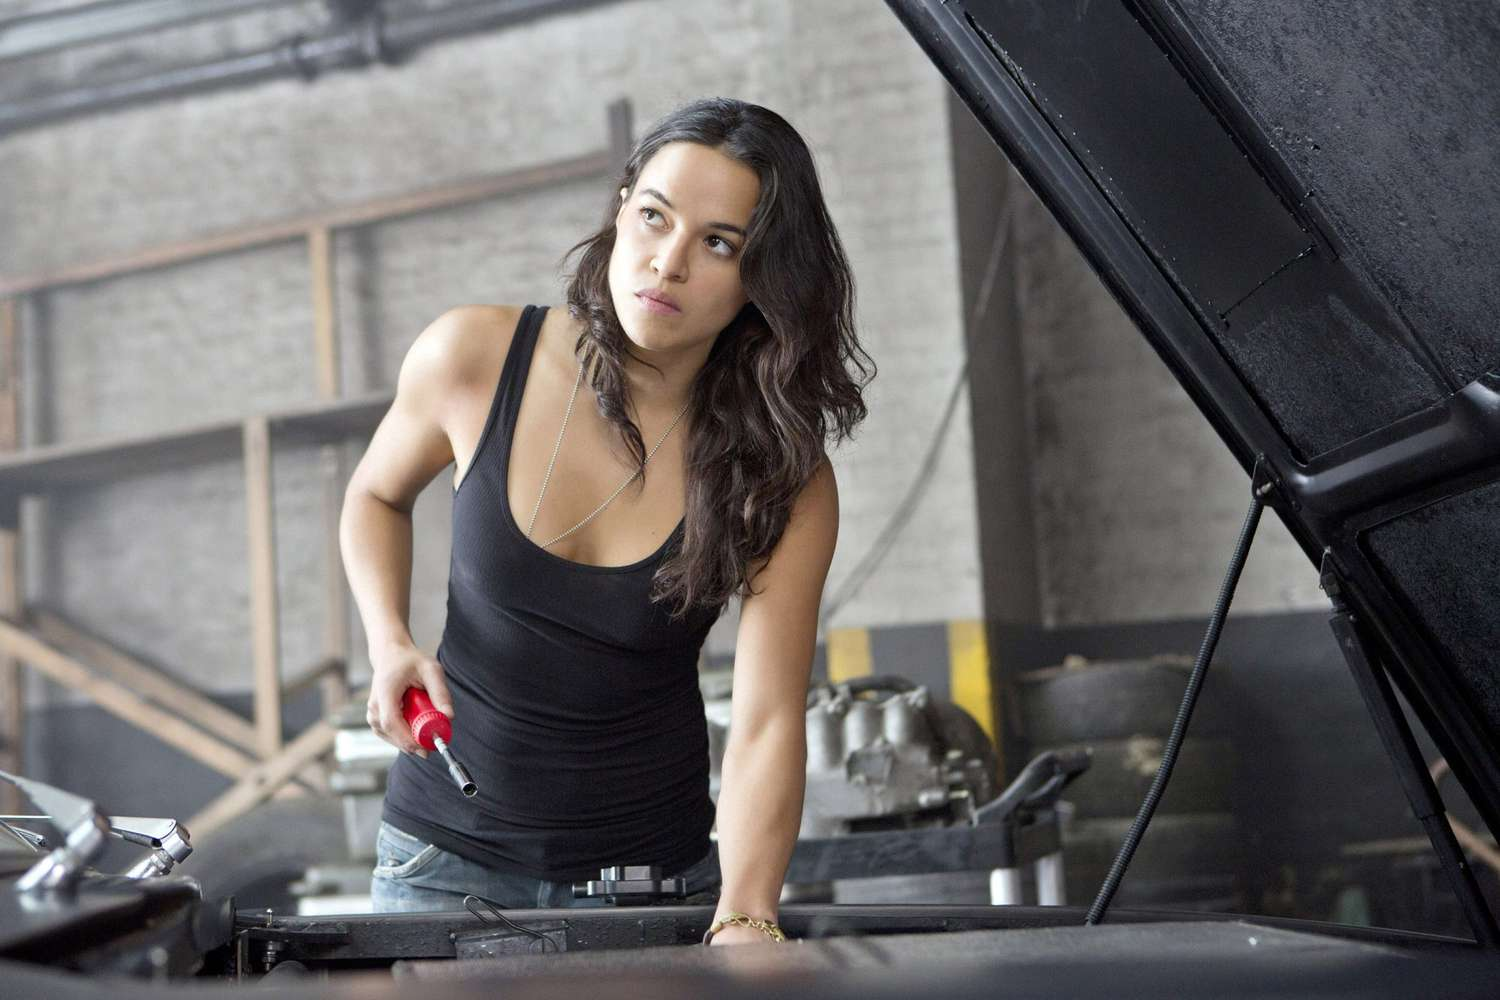What might be the bigger context or story behind this image? This image could be part of a larger narrative about a woman defying stereotypes and thriving in a traditionally male-dominated field. Perhaps she runs her own garage after years of working in less supportive environments. Her backstory might include overcoming personal and professional challenges, gaining respect and trust from her community. This moment captured in the image shows her at her element, demonstrating her expertise and confidence. It’s a snapshot of her daily life but reveals a deeper story of resilience, passion, and breaking barriers. 